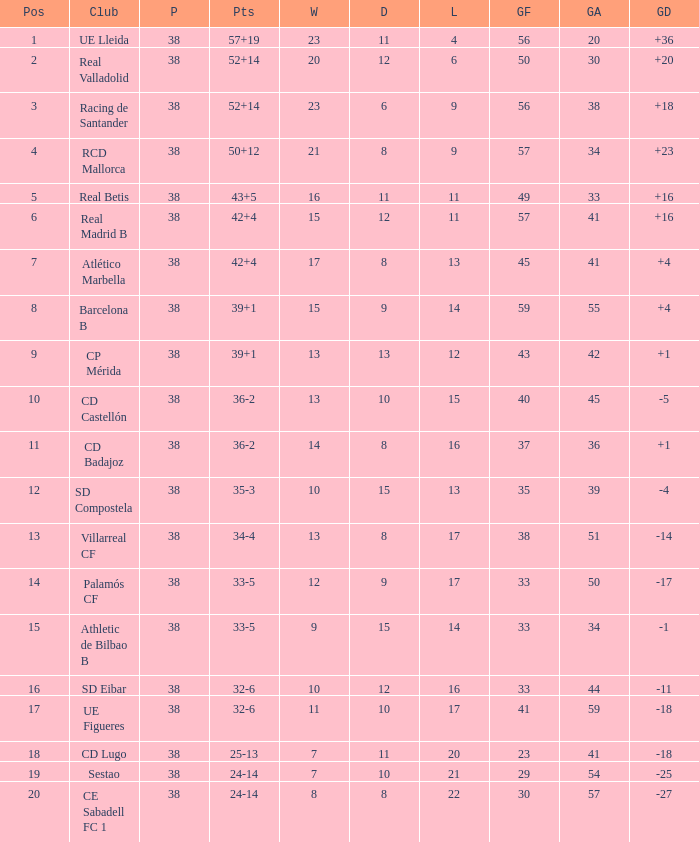Give me the full table as a dictionary. {'header': ['Pos', 'Club', 'P', 'Pts', 'W', 'D', 'L', 'GF', 'GA', 'GD'], 'rows': [['1', 'UE Lleida', '38', '57+19', '23', '11', '4', '56', '20', '+36'], ['2', 'Real Valladolid', '38', '52+14', '20', '12', '6', '50', '30', '+20'], ['3', 'Racing de Santander', '38', '52+14', '23', '6', '9', '56', '38', '+18'], ['4', 'RCD Mallorca', '38', '50+12', '21', '8', '9', '57', '34', '+23'], ['5', 'Real Betis', '38', '43+5', '16', '11', '11', '49', '33', '+16'], ['6', 'Real Madrid B', '38', '42+4', '15', '12', '11', '57', '41', '+16'], ['7', 'Atlético Marbella', '38', '42+4', '17', '8', '13', '45', '41', '+4'], ['8', 'Barcelona B', '38', '39+1', '15', '9', '14', '59', '55', '+4'], ['9', 'CP Mérida', '38', '39+1', '13', '13', '12', '43', '42', '+1'], ['10', 'CD Castellón', '38', '36-2', '13', '10', '15', '40', '45', '-5'], ['11', 'CD Badajoz', '38', '36-2', '14', '8', '16', '37', '36', '+1'], ['12', 'SD Compostela', '38', '35-3', '10', '15', '13', '35', '39', '-4'], ['13', 'Villarreal CF', '38', '34-4', '13', '8', '17', '38', '51', '-14'], ['14', 'Palamós CF', '38', '33-5', '12', '9', '17', '33', '50', '-17'], ['15', 'Athletic de Bilbao B', '38', '33-5', '9', '15', '14', '33', '34', '-1'], ['16', 'SD Eibar', '38', '32-6', '10', '12', '16', '33', '44', '-11'], ['17', 'UE Figueres', '38', '32-6', '11', '10', '17', '41', '59', '-18'], ['18', 'CD Lugo', '38', '25-13', '7', '11', '20', '23', '41', '-18'], ['19', 'Sestao', '38', '24-14', '7', '10', '21', '29', '54', '-25'], ['20', 'CE Sabadell FC 1', '38', '24-14', '8', '8', '22', '30', '57', '-27']]} What is the lowest position with 32-6 points and less then 59 goals when there are more than 38 played? None. 